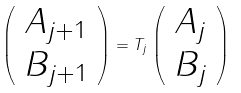Convert formula to latex. <formula><loc_0><loc_0><loc_500><loc_500>\left ( \begin{array} { c } A _ { j + 1 } \\ B _ { j + 1 } \end{array} \right ) = T _ { j } \left ( \begin{array} { c } A _ { j } \\ B _ { j } \end{array} \right )</formula> 